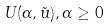Convert formula to latex. <formula><loc_0><loc_0><loc_500><loc_500>U ( \alpha , \tilde { u } ) , \alpha \geq 0</formula> 